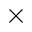Convert formula to latex. <formula><loc_0><loc_0><loc_500><loc_500>\times</formula> 